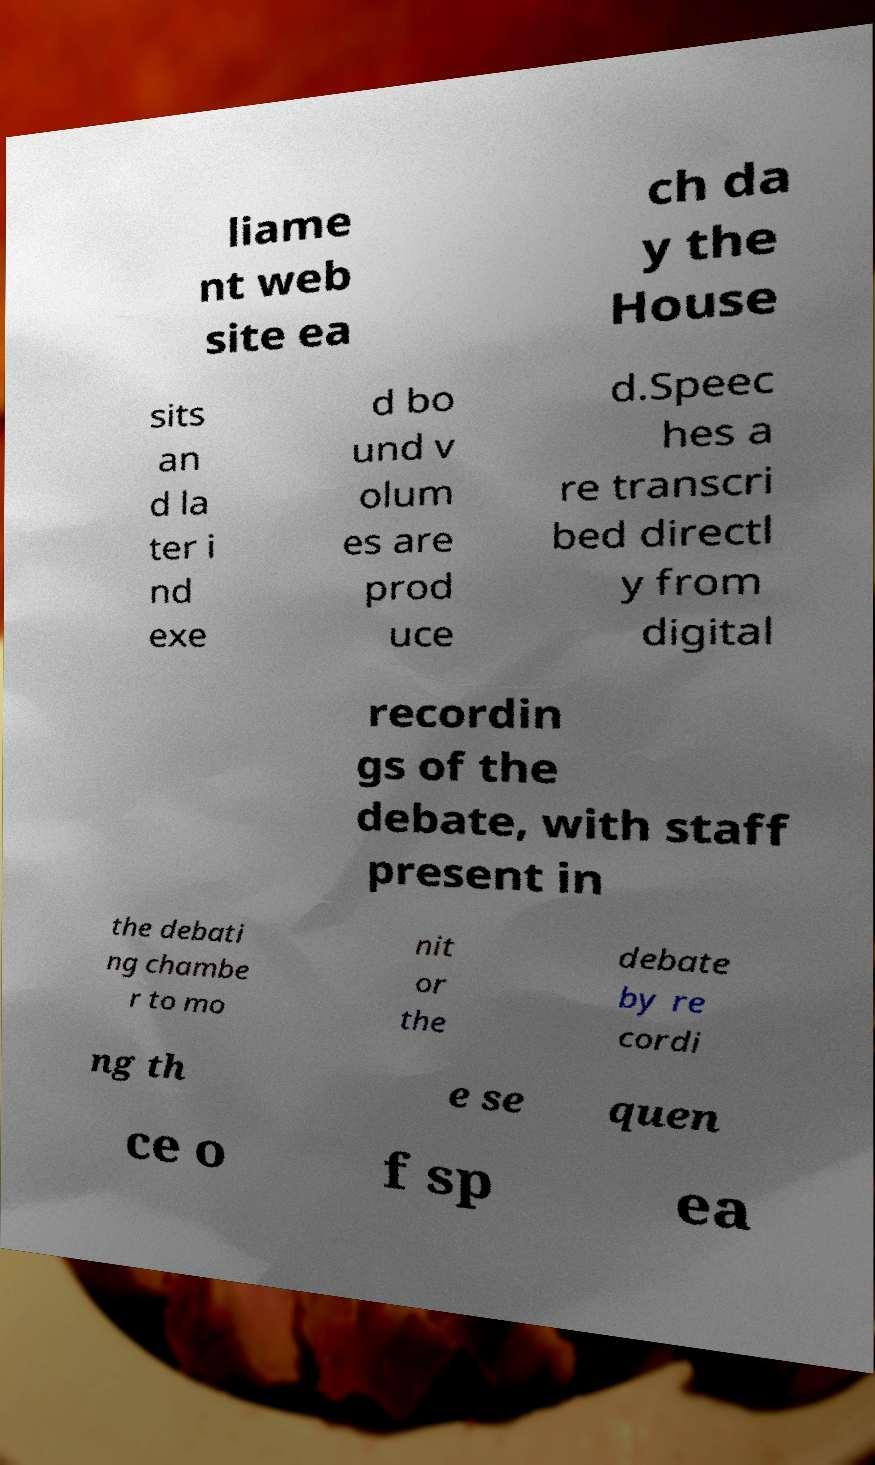Can you read and provide the text displayed in the image?This photo seems to have some interesting text. Can you extract and type it out for me? liame nt web site ea ch da y the House sits an d la ter i nd exe d bo und v olum es are prod uce d.Speec hes a re transcri bed directl y from digital recordin gs of the debate, with staff present in the debati ng chambe r to mo nit or the debate by re cordi ng th e se quen ce o f sp ea 